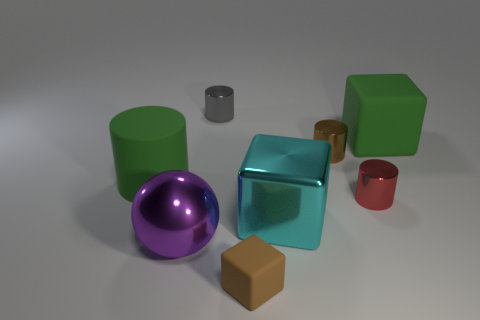Subtract 1 cylinders. How many cylinders are left? 3 Add 1 small cylinders. How many objects exist? 9 Subtract all balls. How many objects are left? 7 Add 3 small red shiny cylinders. How many small red shiny cylinders are left? 4 Add 1 brown cylinders. How many brown cylinders exist? 2 Subtract 1 brown cylinders. How many objects are left? 7 Subtract all gray cylinders. Subtract all red balls. How many objects are left? 7 